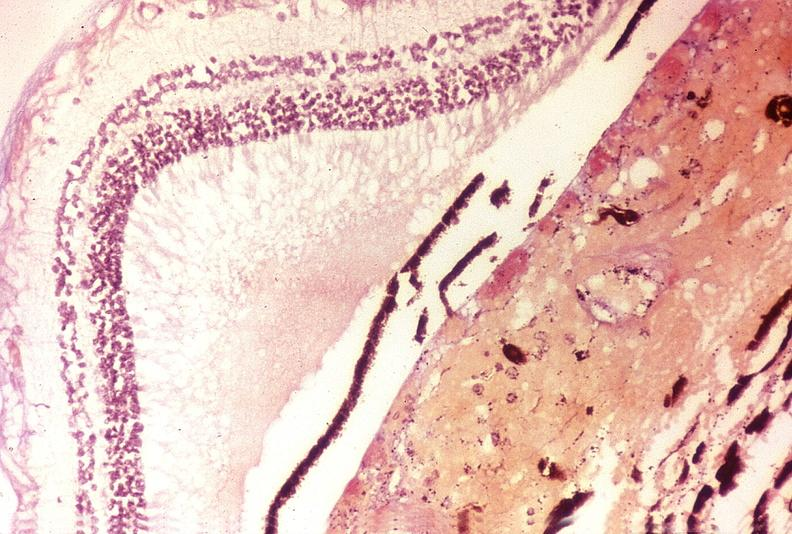what does this image show?
Answer the question using a single word or phrase. Disseminated intravascular coagulation dic 